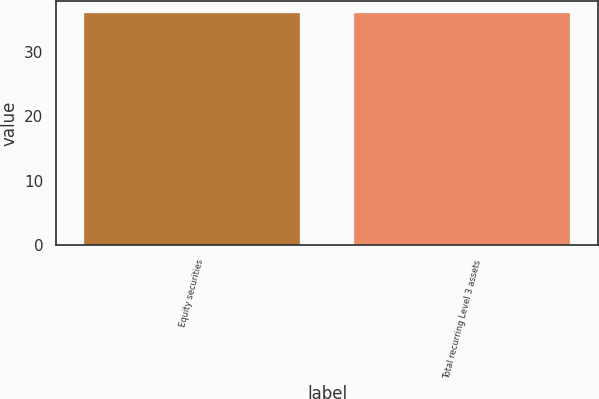Convert chart. <chart><loc_0><loc_0><loc_500><loc_500><bar_chart><fcel>Equity securities<fcel>Total recurring Level 3 assets<nl><fcel>36<fcel>36.1<nl></chart> 